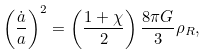<formula> <loc_0><loc_0><loc_500><loc_500>\left ( \frac { \dot { a } } { a } \right ) ^ { 2 } = \left ( \frac { 1 + \chi } { 2 } \right ) \frac { 8 \pi G } { 3 } \rho _ { R } ,</formula> 